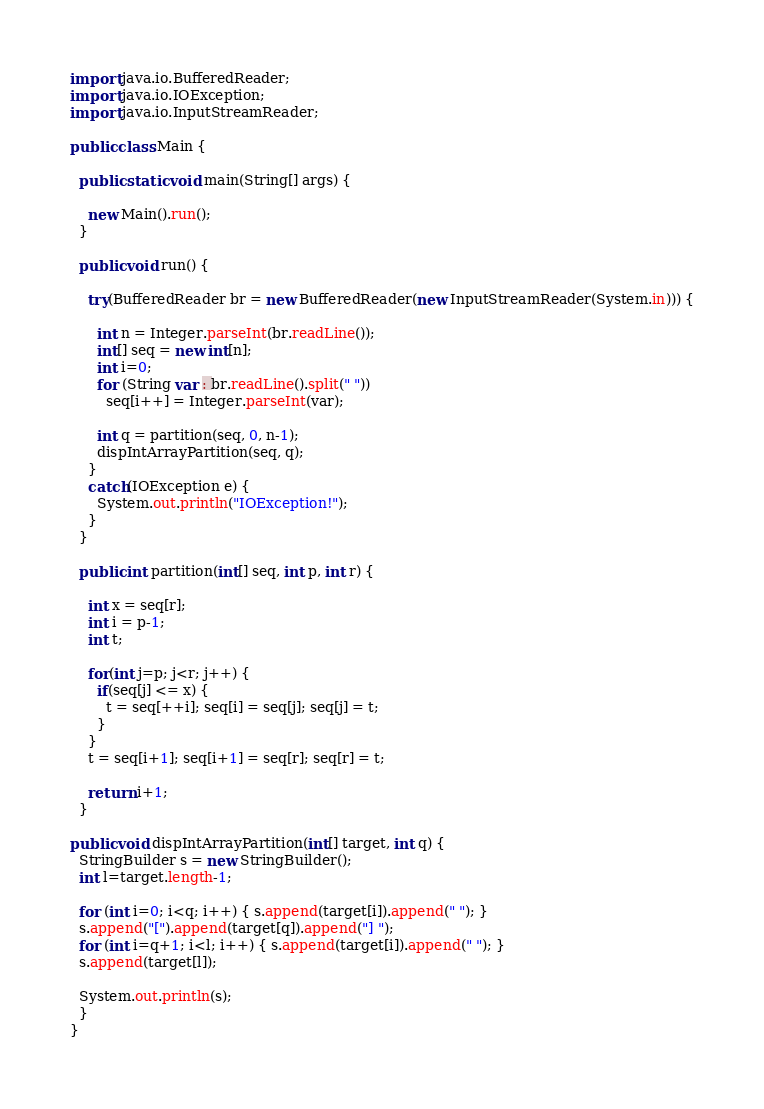<code> <loc_0><loc_0><loc_500><loc_500><_Java_>import java.io.BufferedReader;
import java.io.IOException;
import java.io.InputStreamReader;

public class Main {

  public static void main(String[] args) {
  
    new Main().run();
  }

  public void run() {

    try(BufferedReader br = new BufferedReader(new InputStreamReader(System.in))) {

      int n = Integer.parseInt(br.readLine());
      int[] seq = new int[n];
      int i=0;
      for (String var : br.readLine().split(" "))
        seq[i++] = Integer.parseInt(var);

      int q = partition(seq, 0, n-1);
      dispIntArrayPartition(seq, q);
    }
    catch(IOException e) {
      System.out.println("IOException!");
    }
  }

  public int partition(int[] seq, int p, int r) {

    int x = seq[r];
    int i = p-1;
    int t;

    for(int j=p; j<r; j++) {
      if(seq[j] <= x) {
        t = seq[++i]; seq[i] = seq[j]; seq[j] = t;
      }
    }
    t = seq[i+1]; seq[i+1] = seq[r]; seq[r] = t;

    return i+1;
  }

public void dispIntArrayPartition(int[] target, int q) {
  StringBuilder s = new StringBuilder();
  int l=target.length-1;

  for (int i=0; i<q; i++) { s.append(target[i]).append(" "); }
  s.append("[").append(target[q]).append("] ");
  for (int i=q+1; i<l; i++) { s.append(target[i]).append(" "); }
  s.append(target[l]);

  System.out.println(s);
  }
}
</code> 